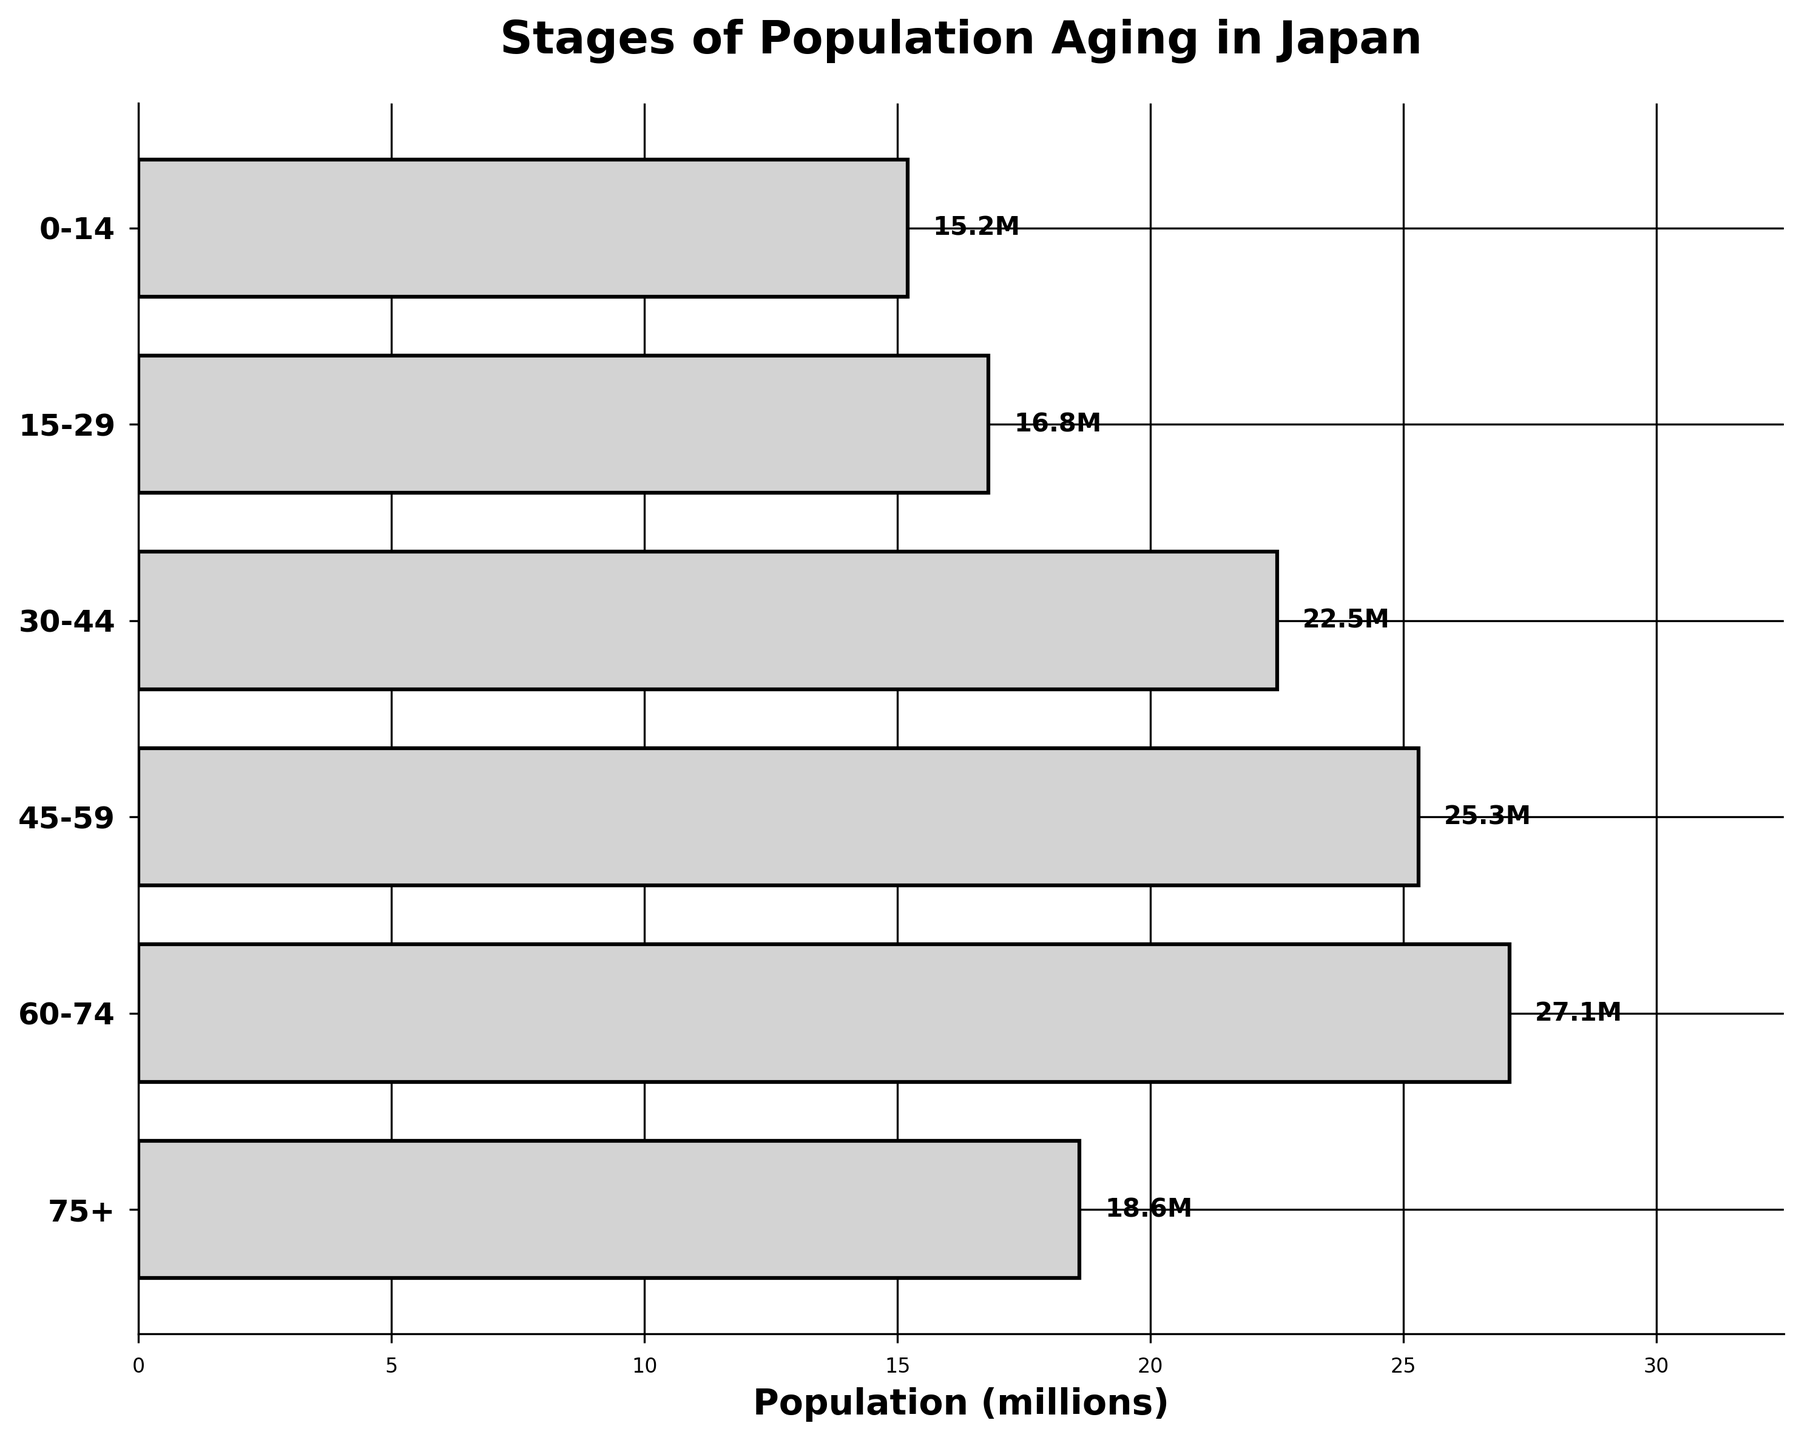What is the title of the chart? The chart title is typically located at the top and provides an overarching description of the chart. In this case, it states the chart's focus on population aging in Japan.
Answer: Stages of Population Aging in Japan What is the population of the 30-44 age group? To find the population of a specific age group, look at the corresponding bar on the chart and read the labeled value right next to it.
Answer: 22.5 million Which age group has the highest population? To determine the age group with the highest population, compare the lengths of the bars and identify the longest one. This represents the age group with the most significant number.
Answer: 60-74 age group What is the total population of all age groups combined? Sum the population values of all age groups: 15.2 + 16.8 + 22.5 + 25.3 + 27.1 + 18.6.
Answer: 125.5 million How much larger is the population of the 45-59 age group compared to the 0-14 age group? Subtract the population of the 0-14 age group from that of the 45-59 age group: 25.3 - 15.2.
Answer: 10.1 million Which age group has the smallest population? Identify the age group with the shortest bar by visually comparing all the bars in the chart.
Answer: 0-14 age group What proportion of the total population does the 75+ age group represent? Calculate the proportion by dividing the 75+ age group's population by the total population and then multiplying by 100 to get the percentage: (18.6 / 125.5) * 100.
Answer: 14.8% Is the population of the 0-14 age group greater or smaller than the population of the 75+ age group? Compare the lengths of the respective bars for both age groups to determine which is longer and hence has a larger population.
Answer: Smaller What is the average population of all age groups? Calculate the average by summing the populations of all age groups and then dividing by the number of age groups: (15.2 + 16.8 + 22.5 + 25.3 + 27.1 + 18.6) / 6.
Answer: 20.92 million Is the population steadily increasing or decreasing with age? To determine the trend, observe the pattern of the bar lengths. Increasing lengths indicate increasing populations, while decreasing lengths indicate decreasing populations.
Answer: Increasing until 60-74, then decreasing 